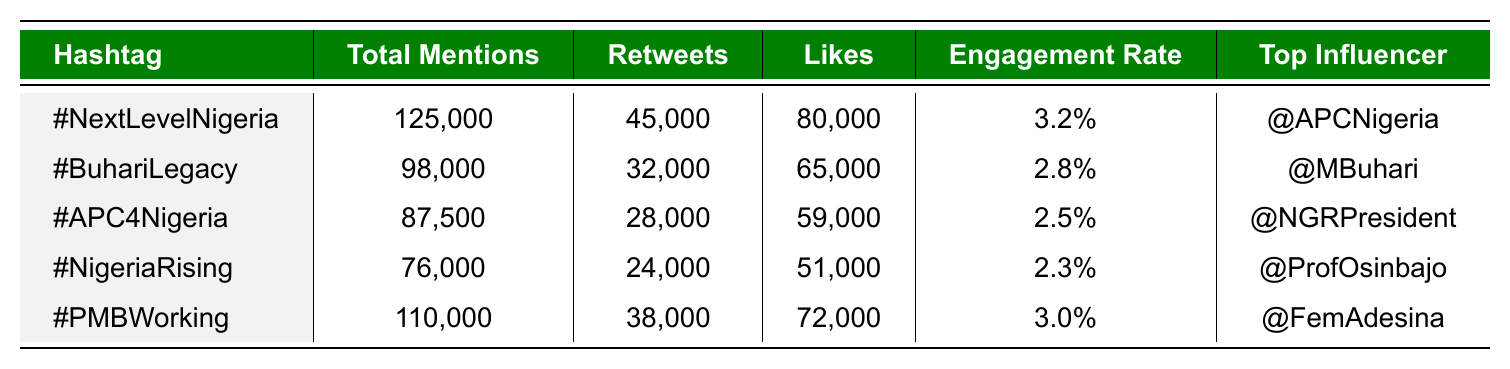What is the total number of mentions for the hashtag #PMBWorking? Referring to the table, the total mentions for #PMBWorking is directly listed under “Total Mentions” as 110,000.
Answer: 110,000 Which hashtag has the highest engagement rate? Looking at the “Engagement Rate” column, #NextLevelNigeria has the highest value of 3.2%.
Answer: #NextLevelNigeria How many more likes does #BuhariLegacy have compared to #NigeriaRising? To find the difference, subtract the likes for #NigeriaRising (51,000) from #BuhariLegacy (65,000): 65,000 - 51,000 = 14,000.
Answer: 14,000 Is it true that #APC4Nigeria has more retweets than likes? For #APC4Nigeria, the retweets (28,000) are less than the likes (59,000), therefore the statement is false.
Answer: No What is the average total mentions for all the hashtags? Adding all mentions: 125,000 + 98,000 + 87,500 + 76,000 + 110,000 = 496,500. Then divide by the number of hashtags (5) to get the average: 496,500 / 5 = 99,300.
Answer: 99,300 Which state is the most active for the hashtag #NigeriaRising? The table shows that the most active state for #NigeriaRising is Rivers.
Answer: Rivers What is the total engagement (likes and retweets) for the hashtag #NextLevelNigeria? For #NextLevelNigeria, likes are 80,000 and retweets are 45,000. Adding these together: 80,000 + 45,000 = 125,000.
Answer: 125,000 How do the total mentions of #BuhariLegacy compare to #PMBWorking? The table lists 98,000 for #BuhariLegacy and 110,000 for #PMBWorking. We can see that #PMBWorking has more mentions than #BuhariLegacy, by a difference of 12,000.
Answer: #PMBWorking has more mentions 